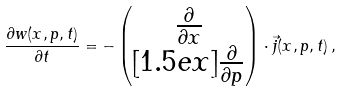<formula> <loc_0><loc_0><loc_500><loc_500>\frac { \partial w ( x , p , t ) } { \partial t } = - \begin{pmatrix} \frac { \partial } { \partial x } \\ [ 1 . 5 e x ] \frac { \partial } { \partial p } \end{pmatrix} \cdot \vec { j } ( x , p , t ) \, ,</formula> 